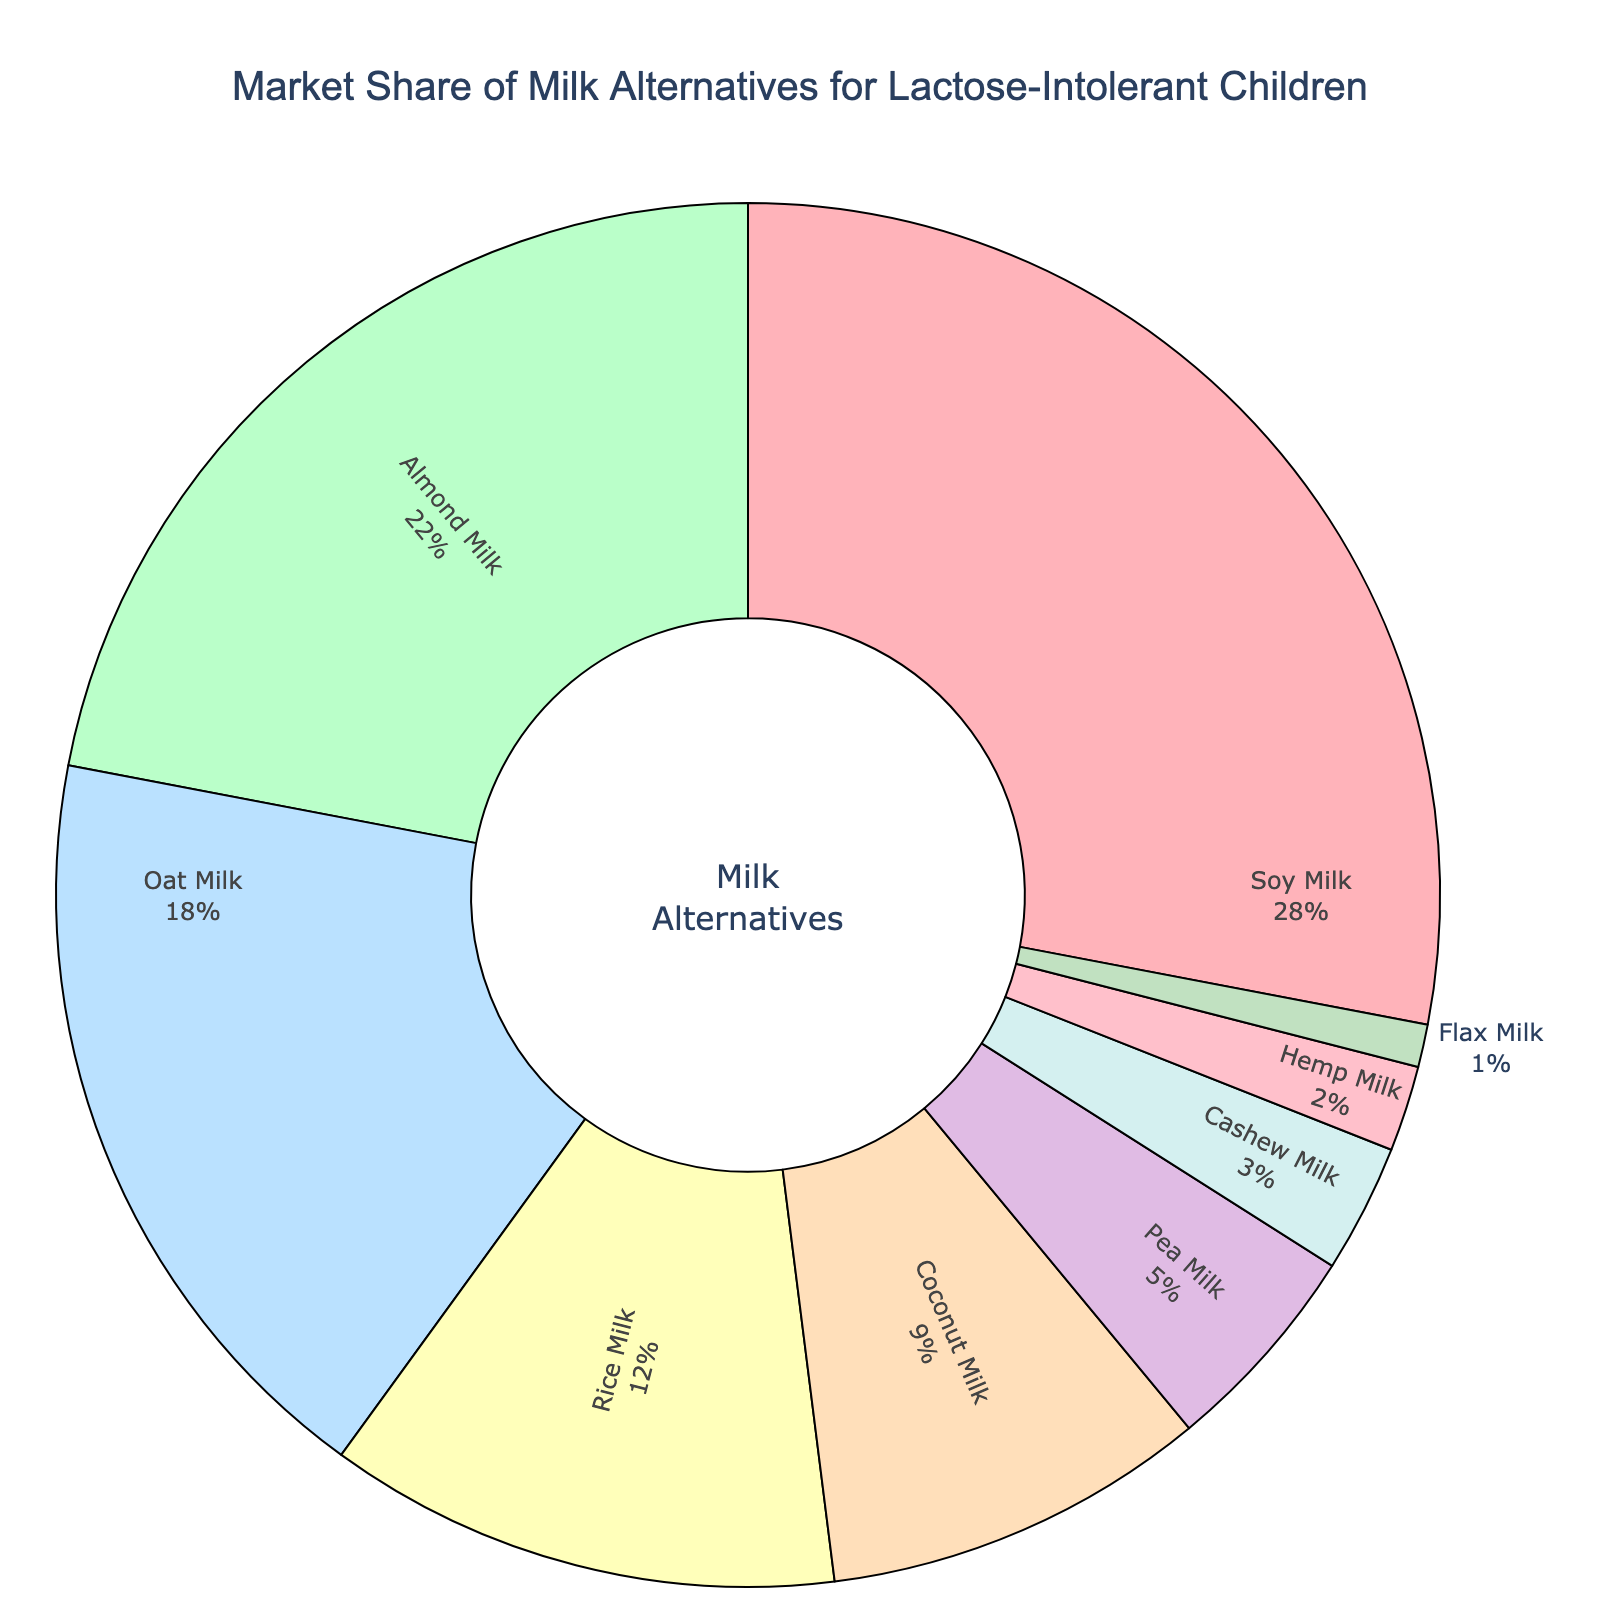What is the market share of Soy Milk? According to the pie chart, the market share of Soy Milk is displayed next to its label.
Answer: 28% Which milk alternative has the smallest market share? From the visual inspection of the pie chart, Flax Milk has the smallest piece of the chart indicating the smallest market share.
Answer: Flax Milk How much greater is the market share of Soy Milk compared to Almond Milk? The market share of Soy Milk is 28% and that of Almond Milk is 22%. The difference is 28% - 22%.
Answer: 6% What is the combined market share of Oat Milk and Rice Milk? From the chart, Oat Milk has an 18% share and Rice Milk has a 12% share. Adding these together yields 18% + 12%.
Answer: 30% Which milk alternatives have a market share greater than or equal to 10%? The pie chart shows that Soy Milk (28%), Almond Milk (22%), Oat Milk (18%), and Rice Milk (12%) all have a market share of 10% or more.
Answer: Soy Milk, Almond Milk, Oat Milk, Rice Milk What is the average market share of non-nut milk alternatives (rice, oat, soy, and pea)? Summing the market shares of Soy Milk (28%), Oat Milk (18%), Rice Milk (12%), and Pea Milk (5%) and then dividing by the number of these alternatives (4): (28% + 18% + 12% + 5%)/4.
Answer: 15.75% Which milk alternative is represented by the green section? Visually inspecting the pie chart, the green section corresponds to Almond Milk.
Answer: Almond Milk Is the combined market share of Coconut Milk and Pea Milk larger than that of Oat Milk? Coconut Milk has a market share of 9% and Pea Milk of 5%, summing these gives 9% + 5% = 14%. Oat Milk has a market share of 18%. 14% is less than 18%.
Answer: No What is the total market share of milk alternatives with a market share less than 10%? Summing the shares of Coconut Milk (9%), Pea Milk (5%), Cashew Milk (3%), Hemp Milk (2%), and Flax Milk (1%): 9% + 5% + 3% + 2% + 1%.
Answer: 20% Which milk alternative has a market share twice as much as Cashew Milk? Cashew Milk has a market share of 3%. The label that shows a market share of 6% is not present, hence there is no milk alternative with exactly twice the market share of Cashew Milk.
Answer: None 